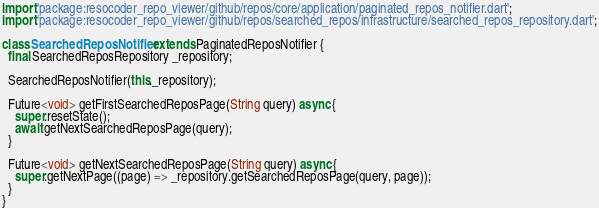Convert code to text. <code><loc_0><loc_0><loc_500><loc_500><_Dart_>import 'package:resocoder_repo_viewer/github/repos/core/application/paginated_repos_notifier.dart';
import 'package:resocoder_repo_viewer/github/repos/searched_repos/infrastructure/searched_repos_repository.dart';

class SearchedReposNotifier extends PaginatedReposNotifier {
  final SearchedReposRepository _repository;

  SearchedReposNotifier(this._repository);

  Future<void> getFirstSearchedReposPage(String query) async {
    super.resetState();
    await getNextSearchedReposPage(query);
  }

  Future<void> getNextSearchedReposPage(String query) async {
    super.getNextPage((page) => _repository.getSearchedReposPage(query, page));
  }
}
</code> 